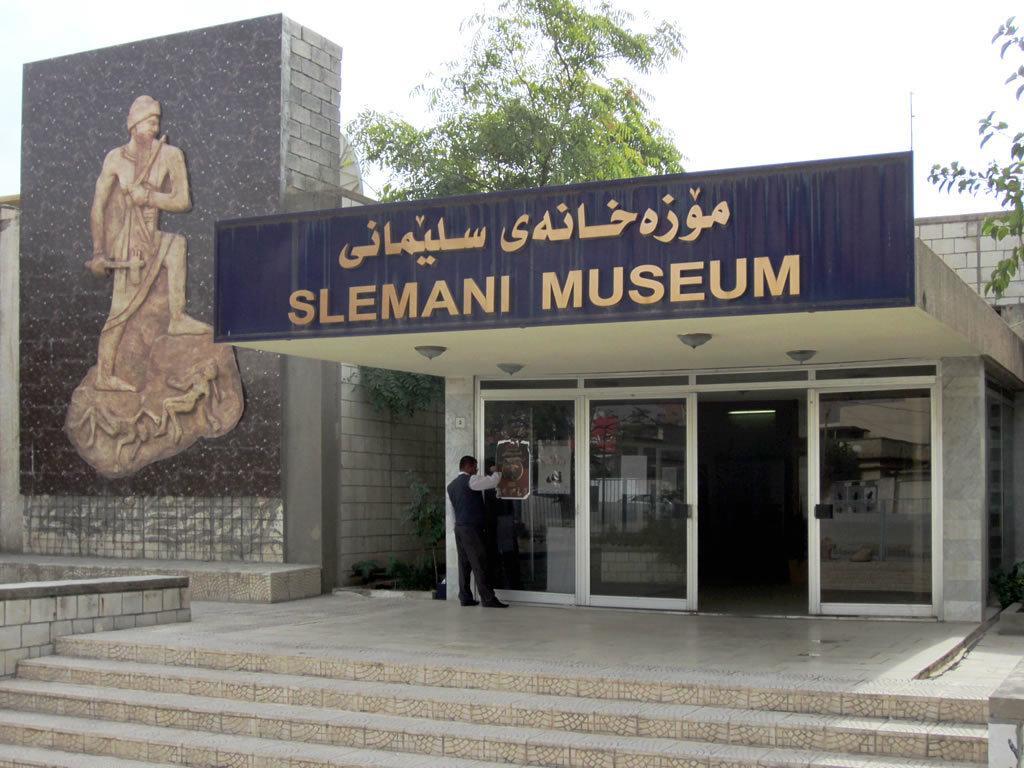Can you describe this image briefly? This is a front view image of slemani museum, in this image this is a person standing on the surface in front of the glass, behind the building there are trees. 